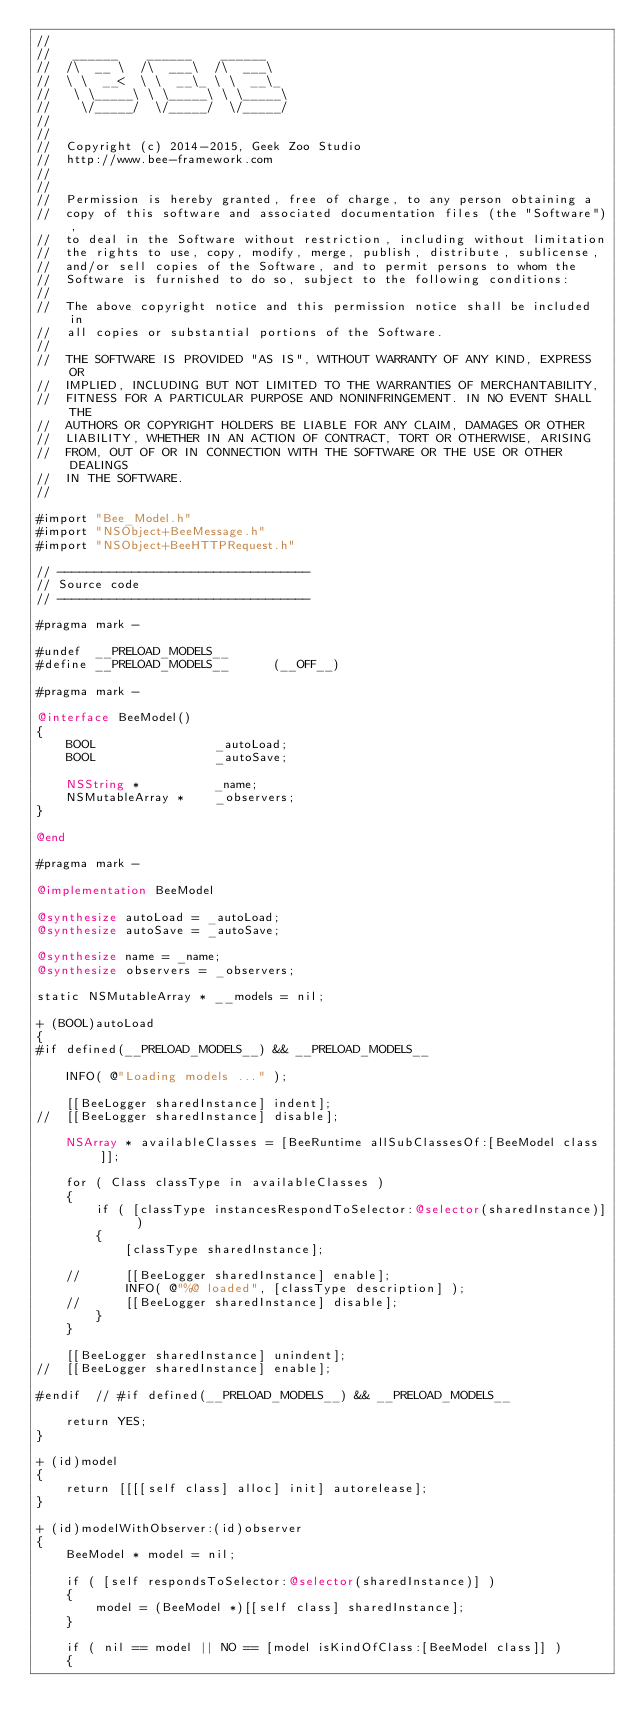Convert code to text. <code><loc_0><loc_0><loc_500><loc_500><_ObjectiveC_>//
//	 ______    ______    ______
//	/\  __ \  /\  ___\  /\  ___\
//	\ \  __<  \ \  __\_ \ \  __\_
//	 \ \_____\ \ \_____\ \ \_____\
//	  \/_____/  \/_____/  \/_____/
//
//
//	Copyright (c) 2014-2015, Geek Zoo Studio
//	http://www.bee-framework.com
//
//
//	Permission is hereby granted, free of charge, to any person obtaining a
//	copy of this software and associated documentation files (the "Software"),
//	to deal in the Software without restriction, including without limitation
//	the rights to use, copy, modify, merge, publish, distribute, sublicense,
//	and/or sell copies of the Software, and to permit persons to whom the
//	Software is furnished to do so, subject to the following conditions:
//
//	The above copyright notice and this permission notice shall be included in
//	all copies or substantial portions of the Software.
//
//	THE SOFTWARE IS PROVIDED "AS IS", WITHOUT WARRANTY OF ANY KIND, EXPRESS OR
//	IMPLIED, INCLUDING BUT NOT LIMITED TO THE WARRANTIES OF MERCHANTABILITY,
//	FITNESS FOR A PARTICULAR PURPOSE AND NONINFRINGEMENT. IN NO EVENT SHALL THE
//	AUTHORS OR COPYRIGHT HOLDERS BE LIABLE FOR ANY CLAIM, DAMAGES OR OTHER
//	LIABILITY, WHETHER IN AN ACTION OF CONTRACT, TORT OR OTHERWISE, ARISING
//	FROM, OUT OF OR IN CONNECTION WITH THE SOFTWARE OR THE USE OR OTHER DEALINGS
//	IN THE SOFTWARE.
//

#import "Bee_Model.h"
#import "NSObject+BeeMessage.h"
#import "NSObject+BeeHTTPRequest.h"

// ----------------------------------
// Source code
// ----------------------------------

#pragma mark -

#undef	__PRELOAD_MODELS__
#define __PRELOAD_MODELS__		(__OFF__)

#pragma mark -

@interface BeeModel()
{
	BOOL				_autoLoad;
	BOOL				_autoSave;

	NSString *			_name;
	NSMutableArray *	_observers;
}

@end

#pragma mark -

@implementation BeeModel

@synthesize autoLoad = _autoLoad;
@synthesize autoSave = _autoSave;

@synthesize name = _name;
@synthesize observers = _observers;

static NSMutableArray *	__models = nil;

+ (BOOL)autoLoad
{
#if defined(__PRELOAD_MODELS__) && __PRELOAD_MODELS__
	
	INFO( @"Loading models ..." );
	
	[[BeeLogger sharedInstance] indent];
//	[[BeeLogger sharedInstance] disable];
	
	NSArray * availableClasses = [BeeRuntime allSubClassesOf:[BeeModel class]];
	
	for ( Class classType in availableClasses )
	{
		if ( [classType instancesRespondToSelector:@selector(sharedInstance)] )
		{
			[classType sharedInstance];
			
	//		[[BeeLogger sharedInstance] enable];
			INFO( @"%@ loaded", [classType description] );
	//		[[BeeLogger sharedInstance] disable];
		}
	}
	
	[[BeeLogger sharedInstance] unindent];
//	[[BeeLogger sharedInstance] enable];
	
#endif	// #if defined(__PRELOAD_MODELS__) && __PRELOAD_MODELS__
	
	return YES;
}

+ (id)model
{
	return [[[[self class] alloc] init] autorelease];
}

+ (id)modelWithObserver:(id)observer
{
	BeeModel * model = nil;

	if ( [self respondsToSelector:@selector(sharedInstance)] )
	{
		model = (BeeModel *)[[self class] sharedInstance];
	}

	if ( nil == model || NO == [model isKindOfClass:[BeeModel class]] )
	{</code> 